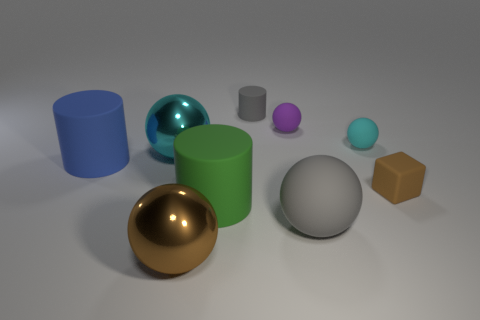Is there a big metal ball? Yes, there is a large metal ball that appears to have a shiny gold surface, reflecting light and its surroundings. 